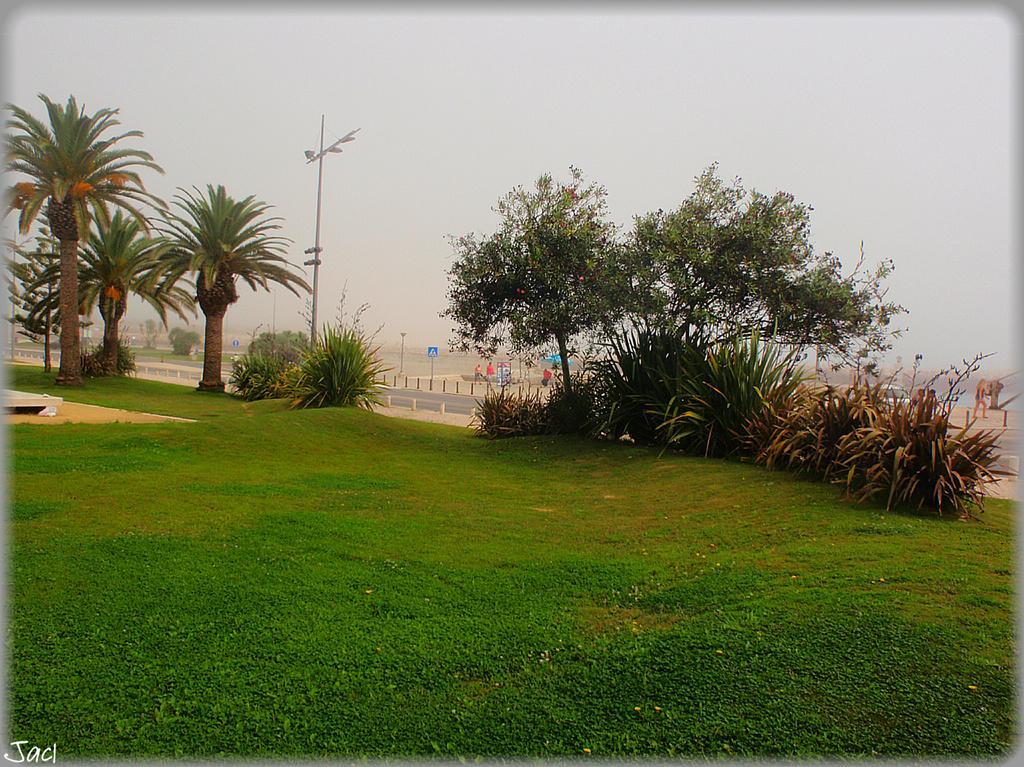Can you describe this image briefly? In this picture there are trees and poles. At the back there are group of people. On the right side of the image there is a vehicle and there is a person walking. At the top there is sky. At the bottom there is grass and there is a road. In the bottom left there is a text. 